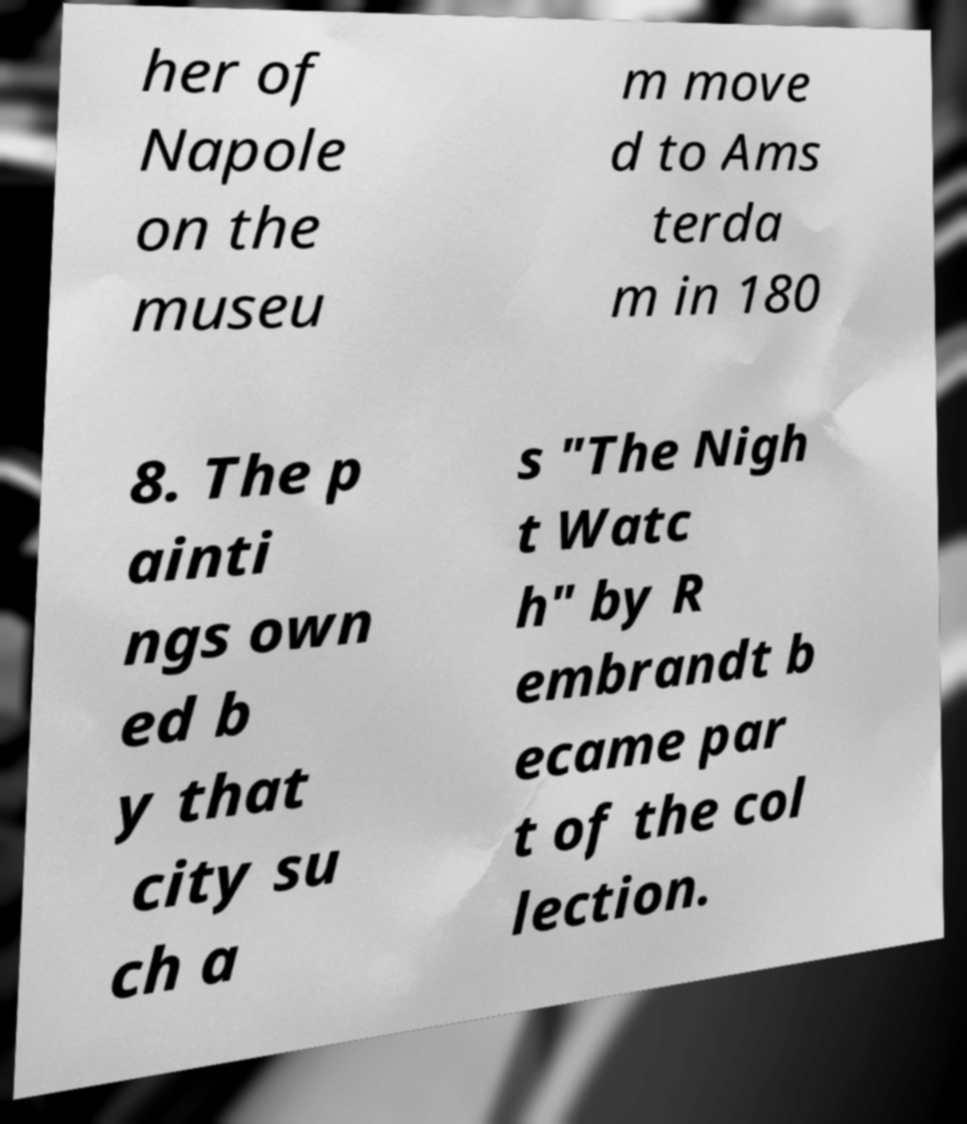For documentation purposes, I need the text within this image transcribed. Could you provide that? her of Napole on the museu m move d to Ams terda m in 180 8. The p ainti ngs own ed b y that city su ch a s "The Nigh t Watc h" by R embrandt b ecame par t of the col lection. 